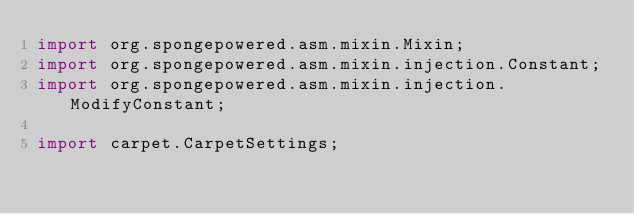Convert code to text. <code><loc_0><loc_0><loc_500><loc_500><_Java_>import org.spongepowered.asm.mixin.Mixin;
import org.spongepowered.asm.mixin.injection.Constant;
import org.spongepowered.asm.mixin.injection.ModifyConstant;

import carpet.CarpetSettings;</code> 